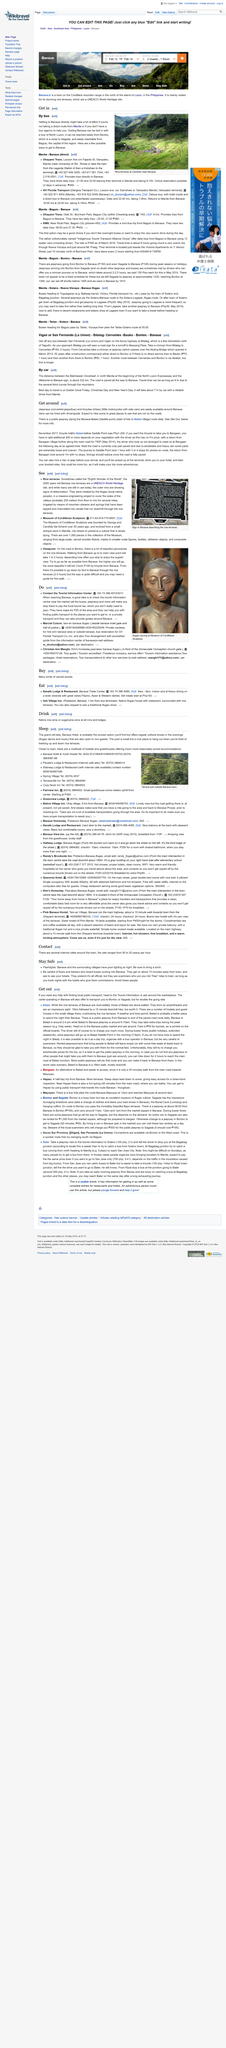Indicate a few pertinent items in this graphic. Banaue is not a better place to spend the night than Batad. The walk from Batad to Banaue is approximately 16 kilometers. A tricycle is commonly referred to as a trike. The article mentions transportation to Bontoc, Sagada, and Batad. The title of this page is "Get Around". 